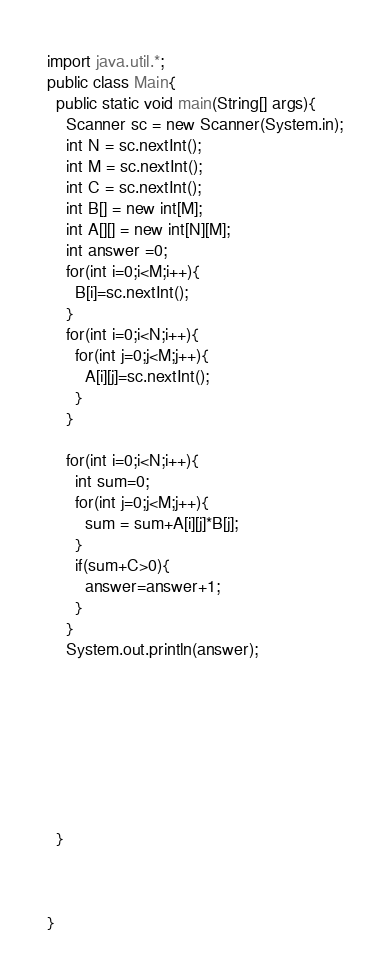Convert code to text. <code><loc_0><loc_0><loc_500><loc_500><_Java_>import java.util.*;
public class Main{
  public static void main(String[] args){
    Scanner sc = new Scanner(System.in);
    int N = sc.nextInt();
    int M = sc.nextInt();
    int C = sc.nextInt();
    int B[] = new int[M];
    int A[][] = new int[N][M];
    int answer =0;
    for(int i=0;i<M;i++){
      B[i]=sc.nextInt();
    }
    for(int i=0;i<N;i++){
      for(int j=0;j<M;j++){
        A[i][j]=sc.nextInt();
      }
    }
    
    for(int i=0;i<N;i++){
      int sum=0;
      for(int j=0;j<M;j++){
        sum = sum+A[i][j]*B[j];
      }
      if(sum+C>0){
        answer=answer+1;
      }
    }
    System.out.println(answer);
      
      
      
      
      
      
    
    
  }
  

  
}</code> 